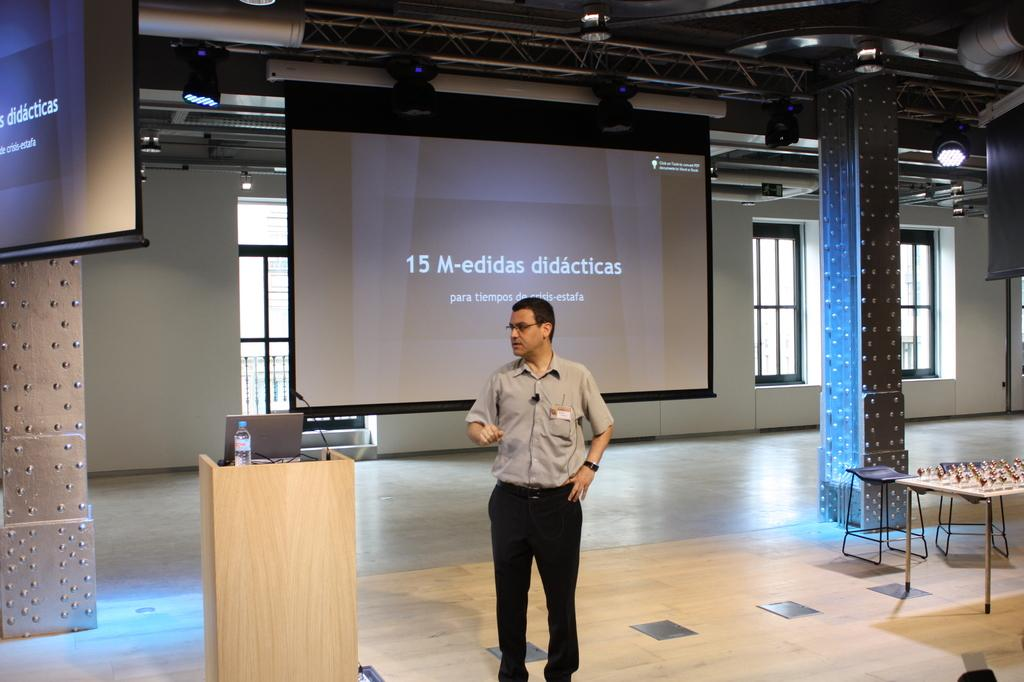<image>
Share a concise interpretation of the image provided. a man with a presentation behind him with the number 15 on it 